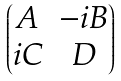<formula> <loc_0><loc_0><loc_500><loc_500>\begin{pmatrix} A & - i B \\ i C & D \end{pmatrix}</formula> 